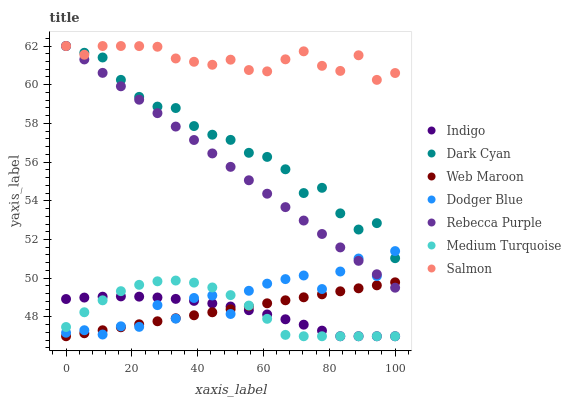Does Indigo have the minimum area under the curve?
Answer yes or no. Yes. Does Salmon have the maximum area under the curve?
Answer yes or no. Yes. Does Web Maroon have the minimum area under the curve?
Answer yes or no. No. Does Web Maroon have the maximum area under the curve?
Answer yes or no. No. Is Web Maroon the smoothest?
Answer yes or no. Yes. Is Dodger Blue the roughest?
Answer yes or no. Yes. Is Salmon the smoothest?
Answer yes or no. No. Is Salmon the roughest?
Answer yes or no. No. Does Indigo have the lowest value?
Answer yes or no. Yes. Does Salmon have the lowest value?
Answer yes or no. No. Does Dark Cyan have the highest value?
Answer yes or no. Yes. Does Web Maroon have the highest value?
Answer yes or no. No. Is Medium Turquoise less than Salmon?
Answer yes or no. Yes. Is Salmon greater than Web Maroon?
Answer yes or no. Yes. Does Indigo intersect Dodger Blue?
Answer yes or no. Yes. Is Indigo less than Dodger Blue?
Answer yes or no. No. Is Indigo greater than Dodger Blue?
Answer yes or no. No. Does Medium Turquoise intersect Salmon?
Answer yes or no. No. 